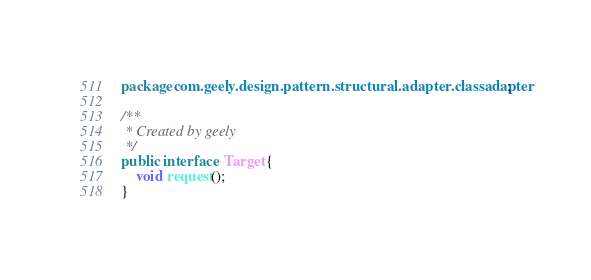<code> <loc_0><loc_0><loc_500><loc_500><_Java_>package com.geely.design.pattern.structural.adapter.classadapter;

/**
 * Created by geely
 */
public interface  Target {
    void request();
}
</code> 